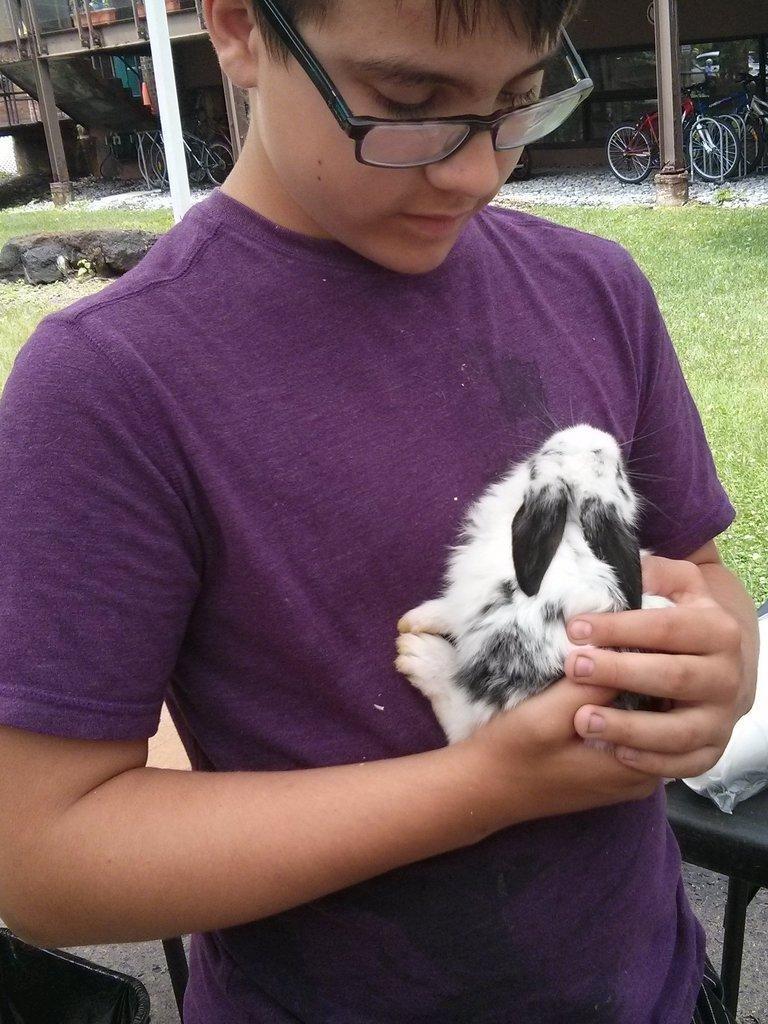Could you give a brief overview of what you see in this image? In this image in front there is a person holding the dog. Behind him there are chairs. At the bottom of the image there is grass on the surface. In the background of the image there are cycles, buildings. 